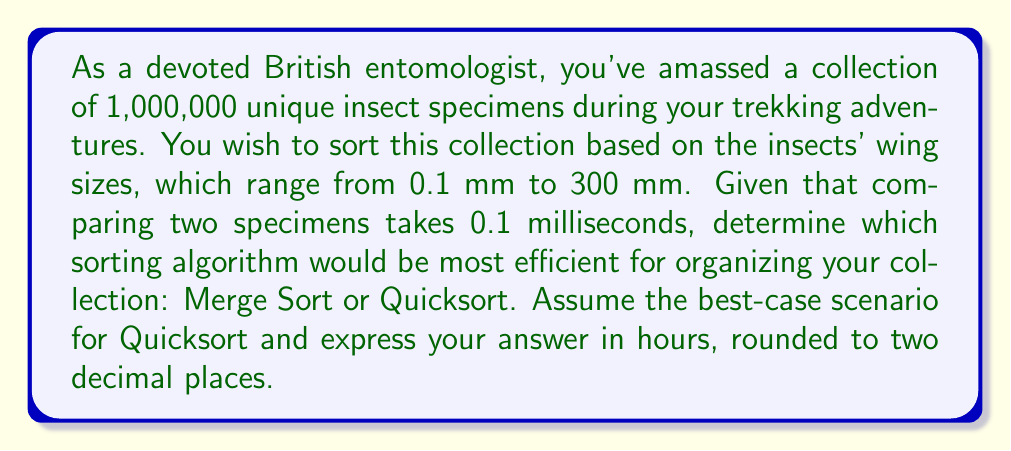Show me your answer to this math problem. To solve this problem, we need to compare the time complexities of Merge Sort and Quicksort, then calculate the actual time taken for each algorithm.

1. Time complexities:
   - Merge Sort: $O(n \log n)$ in all cases
   - Quicksort: $O(n \log n)$ in the best and average cases, $O(n^2)$ in the worst case

2. Number of comparisons:
   - For both algorithms in the best case: $n \log_2 n$
   - $n = 1,000,000$ specimens

3. Calculate the number of comparisons:
   $$1,000,000 \times \log_2(1,000,000) \approx 19,931,568$$

4. Time taken for comparisons:
   $$19,931,568 \times 0.1 \text{ ms} = 1,993,156.8 \text{ ms}$$

5. Convert to hours:
   $$\frac{1,993,156.8 \text{ ms}}{1000 \text{ ms/s} \times 3600 \text{ s/hr}} \approx 0.5536546667 \text{ hours}$$

6. Round to two decimal places:
   $$0.55 \text{ hours}$$

Both Merge Sort and Quicksort (in its best-case scenario) would take approximately the same amount of time to sort the collection.
Answer: 0.55 hours 